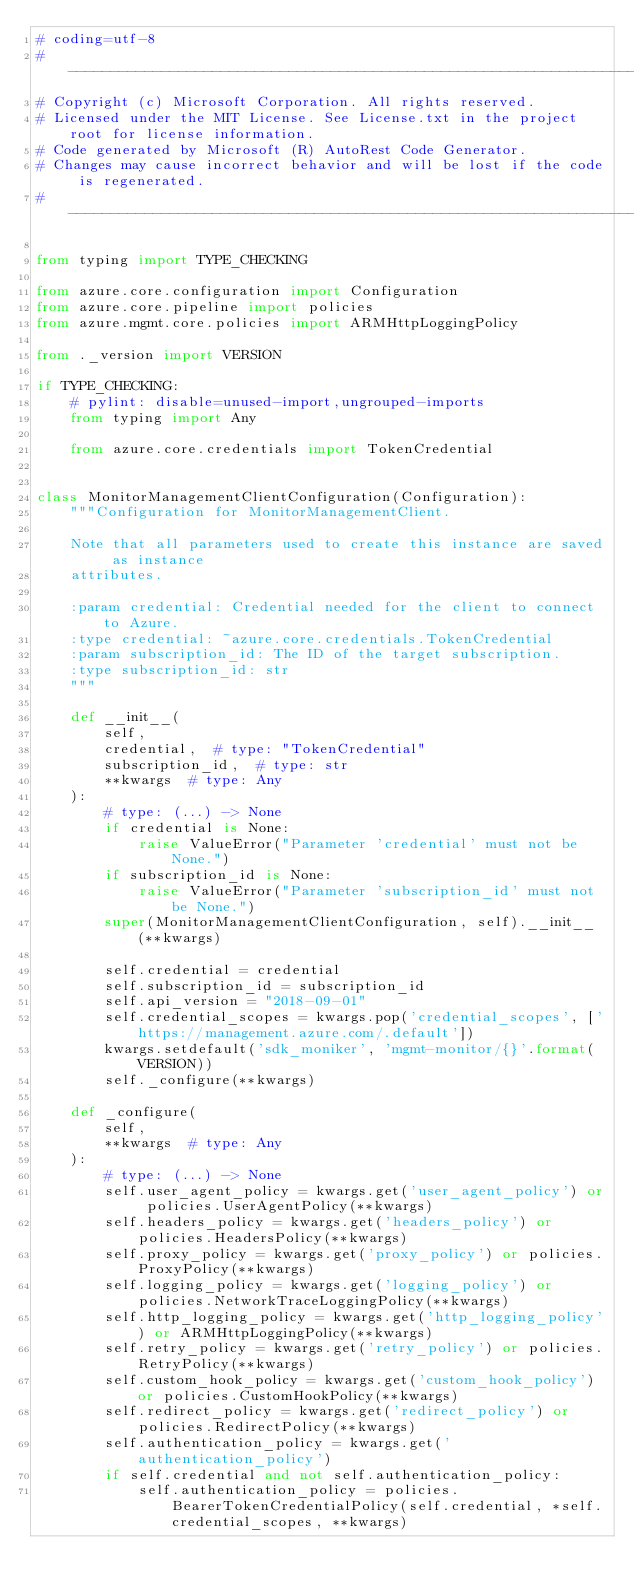Convert code to text. <code><loc_0><loc_0><loc_500><loc_500><_Python_># coding=utf-8
# --------------------------------------------------------------------------
# Copyright (c) Microsoft Corporation. All rights reserved.
# Licensed under the MIT License. See License.txt in the project root for license information.
# Code generated by Microsoft (R) AutoRest Code Generator.
# Changes may cause incorrect behavior and will be lost if the code is regenerated.
# --------------------------------------------------------------------------

from typing import TYPE_CHECKING

from azure.core.configuration import Configuration
from azure.core.pipeline import policies
from azure.mgmt.core.policies import ARMHttpLoggingPolicy

from ._version import VERSION

if TYPE_CHECKING:
    # pylint: disable=unused-import,ungrouped-imports
    from typing import Any

    from azure.core.credentials import TokenCredential


class MonitorManagementClientConfiguration(Configuration):
    """Configuration for MonitorManagementClient.

    Note that all parameters used to create this instance are saved as instance
    attributes.

    :param credential: Credential needed for the client to connect to Azure.
    :type credential: ~azure.core.credentials.TokenCredential
    :param subscription_id: The ID of the target subscription.
    :type subscription_id: str
    """

    def __init__(
        self,
        credential,  # type: "TokenCredential"
        subscription_id,  # type: str
        **kwargs  # type: Any
    ):
        # type: (...) -> None
        if credential is None:
            raise ValueError("Parameter 'credential' must not be None.")
        if subscription_id is None:
            raise ValueError("Parameter 'subscription_id' must not be None.")
        super(MonitorManagementClientConfiguration, self).__init__(**kwargs)

        self.credential = credential
        self.subscription_id = subscription_id
        self.api_version = "2018-09-01"
        self.credential_scopes = kwargs.pop('credential_scopes', ['https://management.azure.com/.default'])
        kwargs.setdefault('sdk_moniker', 'mgmt-monitor/{}'.format(VERSION))
        self._configure(**kwargs)

    def _configure(
        self,
        **kwargs  # type: Any
    ):
        # type: (...) -> None
        self.user_agent_policy = kwargs.get('user_agent_policy') or policies.UserAgentPolicy(**kwargs)
        self.headers_policy = kwargs.get('headers_policy') or policies.HeadersPolicy(**kwargs)
        self.proxy_policy = kwargs.get('proxy_policy') or policies.ProxyPolicy(**kwargs)
        self.logging_policy = kwargs.get('logging_policy') or policies.NetworkTraceLoggingPolicy(**kwargs)
        self.http_logging_policy = kwargs.get('http_logging_policy') or ARMHttpLoggingPolicy(**kwargs)
        self.retry_policy = kwargs.get('retry_policy') or policies.RetryPolicy(**kwargs)
        self.custom_hook_policy = kwargs.get('custom_hook_policy') or policies.CustomHookPolicy(**kwargs)
        self.redirect_policy = kwargs.get('redirect_policy') or policies.RedirectPolicy(**kwargs)
        self.authentication_policy = kwargs.get('authentication_policy')
        if self.credential and not self.authentication_policy:
            self.authentication_policy = policies.BearerTokenCredentialPolicy(self.credential, *self.credential_scopes, **kwargs)
</code> 